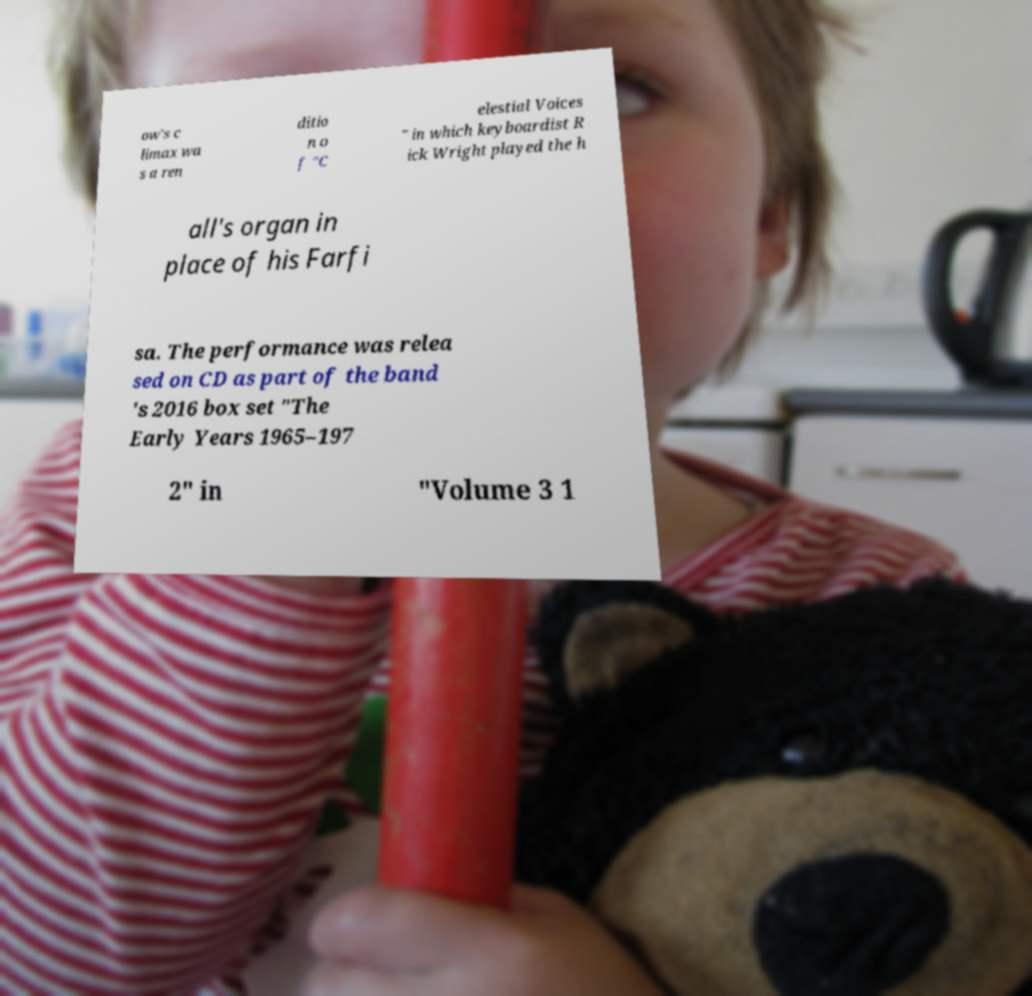I need the written content from this picture converted into text. Can you do that? ow's c limax wa s a ren ditio n o f "C elestial Voices " in which keyboardist R ick Wright played the h all's organ in place of his Farfi sa. The performance was relea sed on CD as part of the band 's 2016 box set "The Early Years 1965–197 2" in "Volume 3 1 